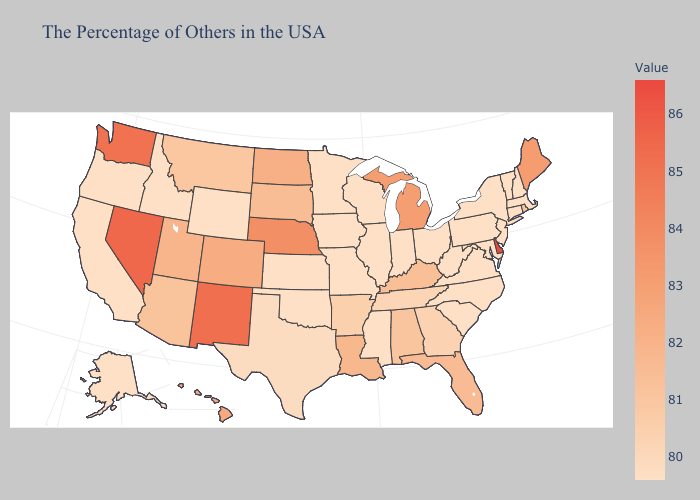Among the states that border Montana , which have the highest value?
Short answer required. North Dakota. Does Arkansas have the lowest value in the USA?
Quick response, please. No. Does the map have missing data?
Short answer required. No. Does Delaware have the highest value in the USA?
Short answer required. Yes. Which states hav the highest value in the MidWest?
Keep it brief. Nebraska. Which states have the lowest value in the USA?
Concise answer only. Massachusetts, New Hampshire, Vermont, Connecticut, New York, New Jersey, Maryland, Pennsylvania, Virginia, North Carolina, South Carolina, West Virginia, Ohio, Indiana, Wisconsin, Illinois, Mississippi, Missouri, Minnesota, Iowa, Kansas, Oklahoma, Wyoming, Idaho, California, Oregon, Alaska. 